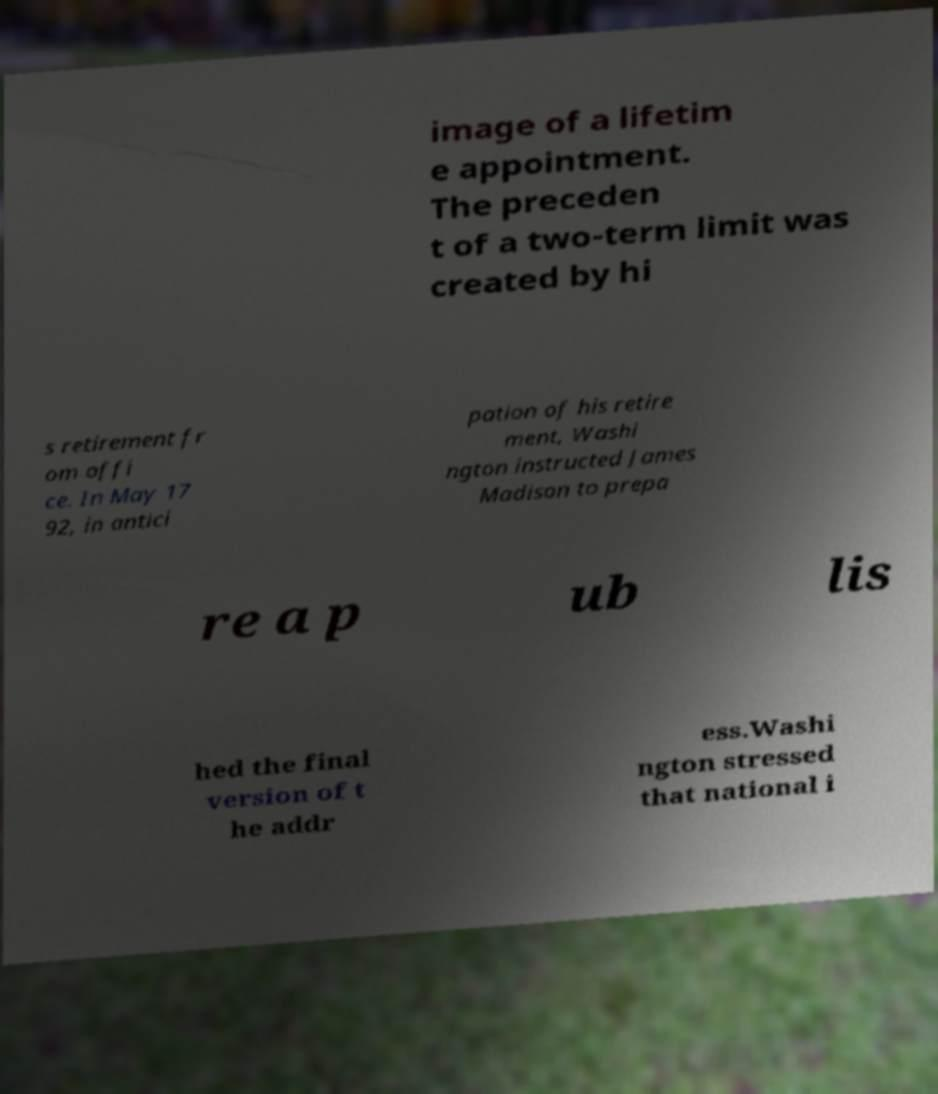Could you extract and type out the text from this image? image of a lifetim e appointment. The preceden t of a two-term limit was created by hi s retirement fr om offi ce. In May 17 92, in antici pation of his retire ment, Washi ngton instructed James Madison to prepa re a p ub lis hed the final version of t he addr ess.Washi ngton stressed that national i 